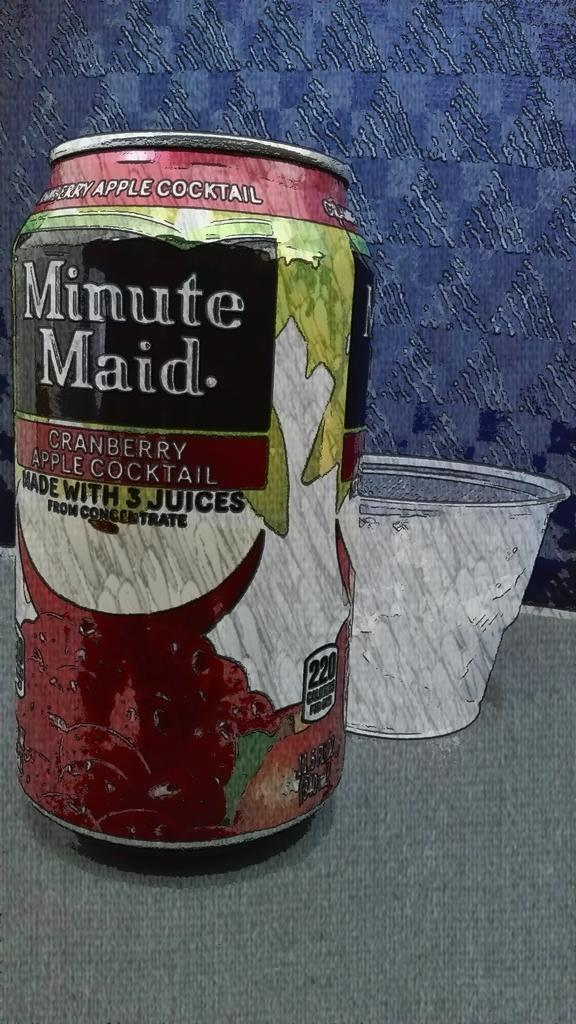<image>
Share a concise interpretation of the image provided. A can of cranberry apple cocktail juice made by Minute Maid. 